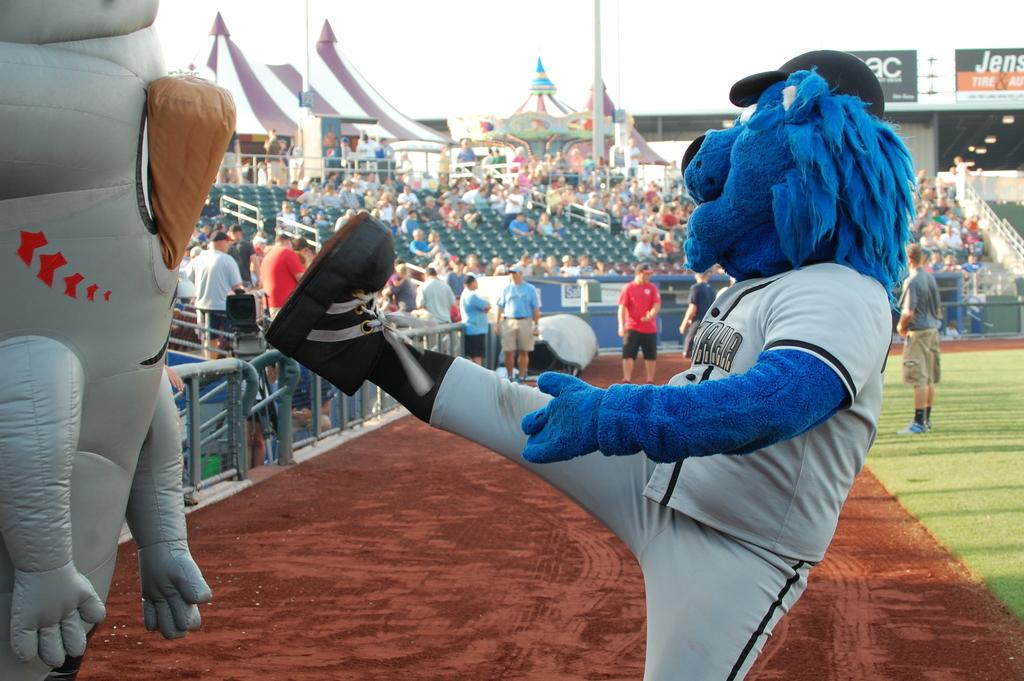<image>
Relay a brief, clear account of the picture shown. The sign above the stand starts with the letters Jens. 